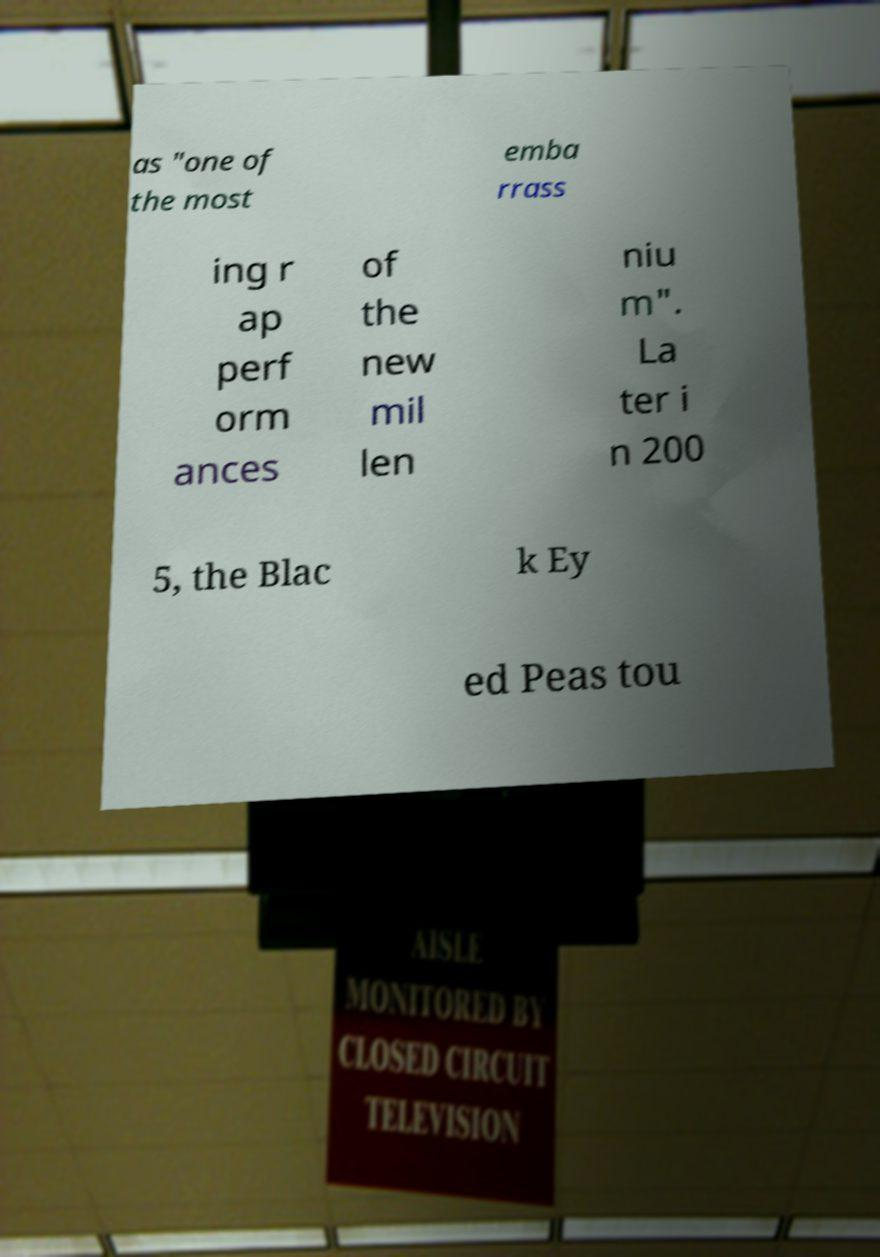Please identify and transcribe the text found in this image. as "one of the most emba rrass ing r ap perf orm ances of the new mil len niu m". La ter i n 200 5, the Blac k Ey ed Peas tou 